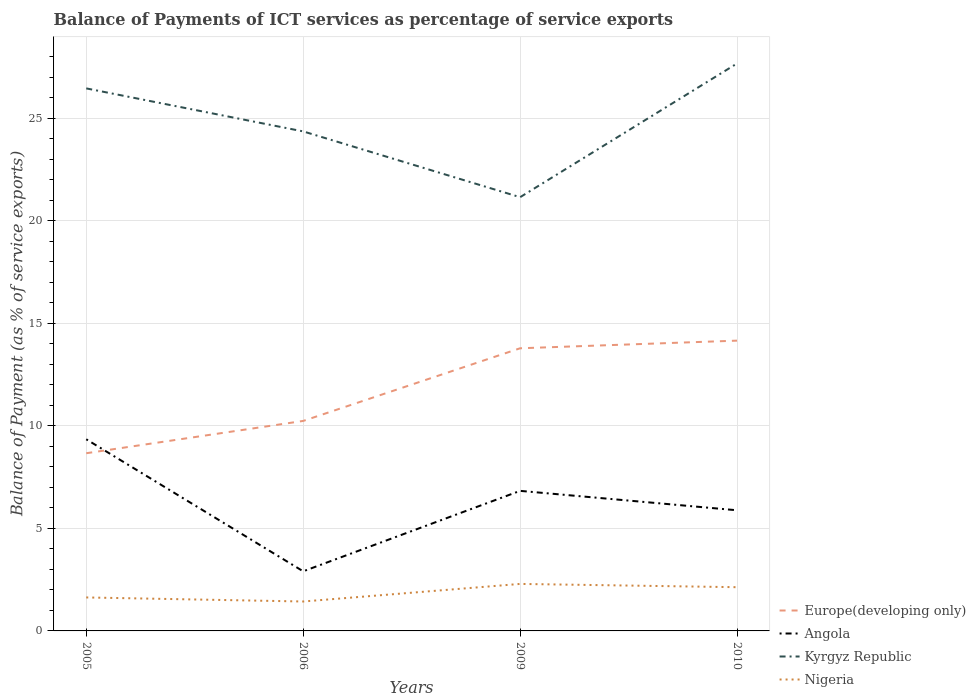How many different coloured lines are there?
Your answer should be very brief. 4. Does the line corresponding to Angola intersect with the line corresponding to Kyrgyz Republic?
Provide a succinct answer. No. Is the number of lines equal to the number of legend labels?
Your answer should be very brief. Yes. Across all years, what is the maximum balance of payments of ICT services in Kyrgyz Republic?
Your answer should be very brief. 21.14. What is the total balance of payments of ICT services in Angola in the graph?
Provide a short and direct response. 3.46. What is the difference between the highest and the second highest balance of payments of ICT services in Kyrgyz Republic?
Offer a very short reply. 6.52. What is the difference between the highest and the lowest balance of payments of ICT services in Europe(developing only)?
Your answer should be compact. 2. How many lines are there?
Provide a succinct answer. 4. How many years are there in the graph?
Your response must be concise. 4. Does the graph contain any zero values?
Keep it short and to the point. No. How are the legend labels stacked?
Offer a very short reply. Vertical. What is the title of the graph?
Provide a short and direct response. Balance of Payments of ICT services as percentage of service exports. Does "Other small states" appear as one of the legend labels in the graph?
Offer a terse response. No. What is the label or title of the X-axis?
Provide a short and direct response. Years. What is the label or title of the Y-axis?
Provide a short and direct response. Balance of Payment (as % of service exports). What is the Balance of Payment (as % of service exports) in Europe(developing only) in 2005?
Offer a terse response. 8.66. What is the Balance of Payment (as % of service exports) of Angola in 2005?
Ensure brevity in your answer.  9.34. What is the Balance of Payment (as % of service exports) in Kyrgyz Republic in 2005?
Give a very brief answer. 26.45. What is the Balance of Payment (as % of service exports) of Nigeria in 2005?
Provide a succinct answer. 1.63. What is the Balance of Payment (as % of service exports) of Europe(developing only) in 2006?
Ensure brevity in your answer.  10.24. What is the Balance of Payment (as % of service exports) of Angola in 2006?
Provide a short and direct response. 2.91. What is the Balance of Payment (as % of service exports) of Kyrgyz Republic in 2006?
Offer a terse response. 24.35. What is the Balance of Payment (as % of service exports) of Nigeria in 2006?
Provide a succinct answer. 1.43. What is the Balance of Payment (as % of service exports) in Europe(developing only) in 2009?
Provide a short and direct response. 13.78. What is the Balance of Payment (as % of service exports) of Angola in 2009?
Your answer should be compact. 6.83. What is the Balance of Payment (as % of service exports) of Kyrgyz Republic in 2009?
Your answer should be compact. 21.14. What is the Balance of Payment (as % of service exports) in Nigeria in 2009?
Offer a terse response. 2.29. What is the Balance of Payment (as % of service exports) of Europe(developing only) in 2010?
Keep it short and to the point. 14.15. What is the Balance of Payment (as % of service exports) in Angola in 2010?
Offer a very short reply. 5.88. What is the Balance of Payment (as % of service exports) of Kyrgyz Republic in 2010?
Give a very brief answer. 27.66. What is the Balance of Payment (as % of service exports) of Nigeria in 2010?
Offer a very short reply. 2.13. Across all years, what is the maximum Balance of Payment (as % of service exports) of Europe(developing only)?
Provide a succinct answer. 14.15. Across all years, what is the maximum Balance of Payment (as % of service exports) in Angola?
Provide a succinct answer. 9.34. Across all years, what is the maximum Balance of Payment (as % of service exports) in Kyrgyz Republic?
Offer a very short reply. 27.66. Across all years, what is the maximum Balance of Payment (as % of service exports) of Nigeria?
Your response must be concise. 2.29. Across all years, what is the minimum Balance of Payment (as % of service exports) in Europe(developing only)?
Your response must be concise. 8.66. Across all years, what is the minimum Balance of Payment (as % of service exports) of Angola?
Provide a short and direct response. 2.91. Across all years, what is the minimum Balance of Payment (as % of service exports) in Kyrgyz Republic?
Offer a very short reply. 21.14. Across all years, what is the minimum Balance of Payment (as % of service exports) in Nigeria?
Give a very brief answer. 1.43. What is the total Balance of Payment (as % of service exports) of Europe(developing only) in the graph?
Ensure brevity in your answer.  46.83. What is the total Balance of Payment (as % of service exports) of Angola in the graph?
Offer a terse response. 24.96. What is the total Balance of Payment (as % of service exports) of Kyrgyz Republic in the graph?
Your response must be concise. 99.6. What is the total Balance of Payment (as % of service exports) in Nigeria in the graph?
Make the answer very short. 7.49. What is the difference between the Balance of Payment (as % of service exports) in Europe(developing only) in 2005 and that in 2006?
Give a very brief answer. -1.57. What is the difference between the Balance of Payment (as % of service exports) of Angola in 2005 and that in 2006?
Provide a short and direct response. 6.44. What is the difference between the Balance of Payment (as % of service exports) in Kyrgyz Republic in 2005 and that in 2006?
Make the answer very short. 2.1. What is the difference between the Balance of Payment (as % of service exports) in Nigeria in 2005 and that in 2006?
Your answer should be compact. 0.2. What is the difference between the Balance of Payment (as % of service exports) of Europe(developing only) in 2005 and that in 2009?
Offer a very short reply. -5.12. What is the difference between the Balance of Payment (as % of service exports) in Angola in 2005 and that in 2009?
Your response must be concise. 2.51. What is the difference between the Balance of Payment (as % of service exports) in Kyrgyz Republic in 2005 and that in 2009?
Your answer should be very brief. 5.3. What is the difference between the Balance of Payment (as % of service exports) in Nigeria in 2005 and that in 2009?
Provide a short and direct response. -0.66. What is the difference between the Balance of Payment (as % of service exports) in Europe(developing only) in 2005 and that in 2010?
Offer a terse response. -5.49. What is the difference between the Balance of Payment (as % of service exports) of Angola in 2005 and that in 2010?
Give a very brief answer. 3.46. What is the difference between the Balance of Payment (as % of service exports) in Kyrgyz Republic in 2005 and that in 2010?
Ensure brevity in your answer.  -1.21. What is the difference between the Balance of Payment (as % of service exports) in Nigeria in 2005 and that in 2010?
Offer a terse response. -0.5. What is the difference between the Balance of Payment (as % of service exports) of Europe(developing only) in 2006 and that in 2009?
Provide a succinct answer. -3.54. What is the difference between the Balance of Payment (as % of service exports) of Angola in 2006 and that in 2009?
Your answer should be compact. -3.92. What is the difference between the Balance of Payment (as % of service exports) of Kyrgyz Republic in 2006 and that in 2009?
Offer a terse response. 3.21. What is the difference between the Balance of Payment (as % of service exports) in Nigeria in 2006 and that in 2009?
Provide a short and direct response. -0.86. What is the difference between the Balance of Payment (as % of service exports) of Europe(developing only) in 2006 and that in 2010?
Give a very brief answer. -3.91. What is the difference between the Balance of Payment (as % of service exports) of Angola in 2006 and that in 2010?
Ensure brevity in your answer.  -2.98. What is the difference between the Balance of Payment (as % of service exports) in Kyrgyz Republic in 2006 and that in 2010?
Keep it short and to the point. -3.31. What is the difference between the Balance of Payment (as % of service exports) in Nigeria in 2006 and that in 2010?
Offer a very short reply. -0.7. What is the difference between the Balance of Payment (as % of service exports) of Europe(developing only) in 2009 and that in 2010?
Offer a very short reply. -0.37. What is the difference between the Balance of Payment (as % of service exports) of Angola in 2009 and that in 2010?
Offer a very short reply. 0.95. What is the difference between the Balance of Payment (as % of service exports) of Kyrgyz Republic in 2009 and that in 2010?
Make the answer very short. -6.52. What is the difference between the Balance of Payment (as % of service exports) in Nigeria in 2009 and that in 2010?
Ensure brevity in your answer.  0.16. What is the difference between the Balance of Payment (as % of service exports) in Europe(developing only) in 2005 and the Balance of Payment (as % of service exports) in Angola in 2006?
Keep it short and to the point. 5.76. What is the difference between the Balance of Payment (as % of service exports) in Europe(developing only) in 2005 and the Balance of Payment (as % of service exports) in Kyrgyz Republic in 2006?
Give a very brief answer. -15.69. What is the difference between the Balance of Payment (as % of service exports) in Europe(developing only) in 2005 and the Balance of Payment (as % of service exports) in Nigeria in 2006?
Your answer should be compact. 7.23. What is the difference between the Balance of Payment (as % of service exports) of Angola in 2005 and the Balance of Payment (as % of service exports) of Kyrgyz Republic in 2006?
Make the answer very short. -15.01. What is the difference between the Balance of Payment (as % of service exports) in Angola in 2005 and the Balance of Payment (as % of service exports) in Nigeria in 2006?
Your response must be concise. 7.91. What is the difference between the Balance of Payment (as % of service exports) of Kyrgyz Republic in 2005 and the Balance of Payment (as % of service exports) of Nigeria in 2006?
Make the answer very short. 25.01. What is the difference between the Balance of Payment (as % of service exports) of Europe(developing only) in 2005 and the Balance of Payment (as % of service exports) of Angola in 2009?
Your answer should be very brief. 1.83. What is the difference between the Balance of Payment (as % of service exports) of Europe(developing only) in 2005 and the Balance of Payment (as % of service exports) of Kyrgyz Republic in 2009?
Ensure brevity in your answer.  -12.48. What is the difference between the Balance of Payment (as % of service exports) in Europe(developing only) in 2005 and the Balance of Payment (as % of service exports) in Nigeria in 2009?
Give a very brief answer. 6.37. What is the difference between the Balance of Payment (as % of service exports) of Angola in 2005 and the Balance of Payment (as % of service exports) of Kyrgyz Republic in 2009?
Offer a terse response. -11.8. What is the difference between the Balance of Payment (as % of service exports) of Angola in 2005 and the Balance of Payment (as % of service exports) of Nigeria in 2009?
Give a very brief answer. 7.05. What is the difference between the Balance of Payment (as % of service exports) in Kyrgyz Republic in 2005 and the Balance of Payment (as % of service exports) in Nigeria in 2009?
Offer a very short reply. 24.15. What is the difference between the Balance of Payment (as % of service exports) of Europe(developing only) in 2005 and the Balance of Payment (as % of service exports) of Angola in 2010?
Your answer should be very brief. 2.78. What is the difference between the Balance of Payment (as % of service exports) of Europe(developing only) in 2005 and the Balance of Payment (as % of service exports) of Kyrgyz Republic in 2010?
Your answer should be very brief. -19. What is the difference between the Balance of Payment (as % of service exports) in Europe(developing only) in 2005 and the Balance of Payment (as % of service exports) in Nigeria in 2010?
Make the answer very short. 6.53. What is the difference between the Balance of Payment (as % of service exports) in Angola in 2005 and the Balance of Payment (as % of service exports) in Kyrgyz Republic in 2010?
Offer a terse response. -18.32. What is the difference between the Balance of Payment (as % of service exports) in Angola in 2005 and the Balance of Payment (as % of service exports) in Nigeria in 2010?
Ensure brevity in your answer.  7.21. What is the difference between the Balance of Payment (as % of service exports) in Kyrgyz Republic in 2005 and the Balance of Payment (as % of service exports) in Nigeria in 2010?
Provide a succinct answer. 24.31. What is the difference between the Balance of Payment (as % of service exports) in Europe(developing only) in 2006 and the Balance of Payment (as % of service exports) in Angola in 2009?
Provide a succinct answer. 3.41. What is the difference between the Balance of Payment (as % of service exports) in Europe(developing only) in 2006 and the Balance of Payment (as % of service exports) in Kyrgyz Republic in 2009?
Make the answer very short. -10.91. What is the difference between the Balance of Payment (as % of service exports) in Europe(developing only) in 2006 and the Balance of Payment (as % of service exports) in Nigeria in 2009?
Ensure brevity in your answer.  7.94. What is the difference between the Balance of Payment (as % of service exports) in Angola in 2006 and the Balance of Payment (as % of service exports) in Kyrgyz Republic in 2009?
Provide a short and direct response. -18.24. What is the difference between the Balance of Payment (as % of service exports) in Angola in 2006 and the Balance of Payment (as % of service exports) in Nigeria in 2009?
Provide a short and direct response. 0.61. What is the difference between the Balance of Payment (as % of service exports) of Kyrgyz Republic in 2006 and the Balance of Payment (as % of service exports) of Nigeria in 2009?
Your answer should be compact. 22.06. What is the difference between the Balance of Payment (as % of service exports) in Europe(developing only) in 2006 and the Balance of Payment (as % of service exports) in Angola in 2010?
Provide a short and direct response. 4.36. What is the difference between the Balance of Payment (as % of service exports) in Europe(developing only) in 2006 and the Balance of Payment (as % of service exports) in Kyrgyz Republic in 2010?
Your response must be concise. -17.42. What is the difference between the Balance of Payment (as % of service exports) of Europe(developing only) in 2006 and the Balance of Payment (as % of service exports) of Nigeria in 2010?
Provide a short and direct response. 8.1. What is the difference between the Balance of Payment (as % of service exports) in Angola in 2006 and the Balance of Payment (as % of service exports) in Kyrgyz Republic in 2010?
Offer a terse response. -24.75. What is the difference between the Balance of Payment (as % of service exports) of Angola in 2006 and the Balance of Payment (as % of service exports) of Nigeria in 2010?
Provide a short and direct response. 0.77. What is the difference between the Balance of Payment (as % of service exports) in Kyrgyz Republic in 2006 and the Balance of Payment (as % of service exports) in Nigeria in 2010?
Ensure brevity in your answer.  22.22. What is the difference between the Balance of Payment (as % of service exports) of Europe(developing only) in 2009 and the Balance of Payment (as % of service exports) of Angola in 2010?
Provide a short and direct response. 7.9. What is the difference between the Balance of Payment (as % of service exports) of Europe(developing only) in 2009 and the Balance of Payment (as % of service exports) of Kyrgyz Republic in 2010?
Your answer should be compact. -13.88. What is the difference between the Balance of Payment (as % of service exports) of Europe(developing only) in 2009 and the Balance of Payment (as % of service exports) of Nigeria in 2010?
Provide a short and direct response. 11.65. What is the difference between the Balance of Payment (as % of service exports) of Angola in 2009 and the Balance of Payment (as % of service exports) of Kyrgyz Republic in 2010?
Offer a terse response. -20.83. What is the difference between the Balance of Payment (as % of service exports) of Angola in 2009 and the Balance of Payment (as % of service exports) of Nigeria in 2010?
Provide a succinct answer. 4.7. What is the difference between the Balance of Payment (as % of service exports) of Kyrgyz Republic in 2009 and the Balance of Payment (as % of service exports) of Nigeria in 2010?
Provide a succinct answer. 19.01. What is the average Balance of Payment (as % of service exports) of Europe(developing only) per year?
Keep it short and to the point. 11.71. What is the average Balance of Payment (as % of service exports) of Angola per year?
Provide a succinct answer. 6.24. What is the average Balance of Payment (as % of service exports) in Kyrgyz Republic per year?
Offer a terse response. 24.9. What is the average Balance of Payment (as % of service exports) of Nigeria per year?
Offer a very short reply. 1.87. In the year 2005, what is the difference between the Balance of Payment (as % of service exports) of Europe(developing only) and Balance of Payment (as % of service exports) of Angola?
Offer a very short reply. -0.68. In the year 2005, what is the difference between the Balance of Payment (as % of service exports) of Europe(developing only) and Balance of Payment (as % of service exports) of Kyrgyz Republic?
Make the answer very short. -17.78. In the year 2005, what is the difference between the Balance of Payment (as % of service exports) in Europe(developing only) and Balance of Payment (as % of service exports) in Nigeria?
Your response must be concise. 7.03. In the year 2005, what is the difference between the Balance of Payment (as % of service exports) of Angola and Balance of Payment (as % of service exports) of Kyrgyz Republic?
Your answer should be compact. -17.1. In the year 2005, what is the difference between the Balance of Payment (as % of service exports) of Angola and Balance of Payment (as % of service exports) of Nigeria?
Your answer should be very brief. 7.71. In the year 2005, what is the difference between the Balance of Payment (as % of service exports) of Kyrgyz Republic and Balance of Payment (as % of service exports) of Nigeria?
Offer a terse response. 24.81. In the year 2006, what is the difference between the Balance of Payment (as % of service exports) of Europe(developing only) and Balance of Payment (as % of service exports) of Angola?
Provide a succinct answer. 7.33. In the year 2006, what is the difference between the Balance of Payment (as % of service exports) of Europe(developing only) and Balance of Payment (as % of service exports) of Kyrgyz Republic?
Provide a short and direct response. -14.11. In the year 2006, what is the difference between the Balance of Payment (as % of service exports) in Europe(developing only) and Balance of Payment (as % of service exports) in Nigeria?
Give a very brief answer. 8.8. In the year 2006, what is the difference between the Balance of Payment (as % of service exports) in Angola and Balance of Payment (as % of service exports) in Kyrgyz Republic?
Your response must be concise. -21.44. In the year 2006, what is the difference between the Balance of Payment (as % of service exports) of Angola and Balance of Payment (as % of service exports) of Nigeria?
Your answer should be compact. 1.47. In the year 2006, what is the difference between the Balance of Payment (as % of service exports) in Kyrgyz Republic and Balance of Payment (as % of service exports) in Nigeria?
Provide a succinct answer. 22.92. In the year 2009, what is the difference between the Balance of Payment (as % of service exports) in Europe(developing only) and Balance of Payment (as % of service exports) in Angola?
Provide a short and direct response. 6.95. In the year 2009, what is the difference between the Balance of Payment (as % of service exports) of Europe(developing only) and Balance of Payment (as % of service exports) of Kyrgyz Republic?
Make the answer very short. -7.36. In the year 2009, what is the difference between the Balance of Payment (as % of service exports) in Europe(developing only) and Balance of Payment (as % of service exports) in Nigeria?
Ensure brevity in your answer.  11.49. In the year 2009, what is the difference between the Balance of Payment (as % of service exports) of Angola and Balance of Payment (as % of service exports) of Kyrgyz Republic?
Your answer should be compact. -14.31. In the year 2009, what is the difference between the Balance of Payment (as % of service exports) in Angola and Balance of Payment (as % of service exports) in Nigeria?
Your response must be concise. 4.54. In the year 2009, what is the difference between the Balance of Payment (as % of service exports) of Kyrgyz Republic and Balance of Payment (as % of service exports) of Nigeria?
Offer a very short reply. 18.85. In the year 2010, what is the difference between the Balance of Payment (as % of service exports) of Europe(developing only) and Balance of Payment (as % of service exports) of Angola?
Offer a terse response. 8.27. In the year 2010, what is the difference between the Balance of Payment (as % of service exports) in Europe(developing only) and Balance of Payment (as % of service exports) in Kyrgyz Republic?
Provide a succinct answer. -13.51. In the year 2010, what is the difference between the Balance of Payment (as % of service exports) in Europe(developing only) and Balance of Payment (as % of service exports) in Nigeria?
Make the answer very short. 12.02. In the year 2010, what is the difference between the Balance of Payment (as % of service exports) in Angola and Balance of Payment (as % of service exports) in Kyrgyz Republic?
Your response must be concise. -21.78. In the year 2010, what is the difference between the Balance of Payment (as % of service exports) of Angola and Balance of Payment (as % of service exports) of Nigeria?
Your answer should be very brief. 3.75. In the year 2010, what is the difference between the Balance of Payment (as % of service exports) of Kyrgyz Republic and Balance of Payment (as % of service exports) of Nigeria?
Make the answer very short. 25.53. What is the ratio of the Balance of Payment (as % of service exports) of Europe(developing only) in 2005 to that in 2006?
Offer a very short reply. 0.85. What is the ratio of the Balance of Payment (as % of service exports) of Angola in 2005 to that in 2006?
Provide a succinct answer. 3.21. What is the ratio of the Balance of Payment (as % of service exports) in Kyrgyz Republic in 2005 to that in 2006?
Your response must be concise. 1.09. What is the ratio of the Balance of Payment (as % of service exports) of Nigeria in 2005 to that in 2006?
Provide a succinct answer. 1.14. What is the ratio of the Balance of Payment (as % of service exports) of Europe(developing only) in 2005 to that in 2009?
Your response must be concise. 0.63. What is the ratio of the Balance of Payment (as % of service exports) in Angola in 2005 to that in 2009?
Offer a terse response. 1.37. What is the ratio of the Balance of Payment (as % of service exports) of Kyrgyz Republic in 2005 to that in 2009?
Your answer should be compact. 1.25. What is the ratio of the Balance of Payment (as % of service exports) in Nigeria in 2005 to that in 2009?
Provide a succinct answer. 0.71. What is the ratio of the Balance of Payment (as % of service exports) of Europe(developing only) in 2005 to that in 2010?
Keep it short and to the point. 0.61. What is the ratio of the Balance of Payment (as % of service exports) in Angola in 2005 to that in 2010?
Give a very brief answer. 1.59. What is the ratio of the Balance of Payment (as % of service exports) of Kyrgyz Republic in 2005 to that in 2010?
Your response must be concise. 0.96. What is the ratio of the Balance of Payment (as % of service exports) in Nigeria in 2005 to that in 2010?
Offer a terse response. 0.77. What is the ratio of the Balance of Payment (as % of service exports) in Europe(developing only) in 2006 to that in 2009?
Provide a short and direct response. 0.74. What is the ratio of the Balance of Payment (as % of service exports) in Angola in 2006 to that in 2009?
Keep it short and to the point. 0.43. What is the ratio of the Balance of Payment (as % of service exports) of Kyrgyz Republic in 2006 to that in 2009?
Your answer should be very brief. 1.15. What is the ratio of the Balance of Payment (as % of service exports) in Nigeria in 2006 to that in 2009?
Your response must be concise. 0.63. What is the ratio of the Balance of Payment (as % of service exports) of Europe(developing only) in 2006 to that in 2010?
Make the answer very short. 0.72. What is the ratio of the Balance of Payment (as % of service exports) of Angola in 2006 to that in 2010?
Ensure brevity in your answer.  0.49. What is the ratio of the Balance of Payment (as % of service exports) of Kyrgyz Republic in 2006 to that in 2010?
Provide a succinct answer. 0.88. What is the ratio of the Balance of Payment (as % of service exports) in Nigeria in 2006 to that in 2010?
Keep it short and to the point. 0.67. What is the ratio of the Balance of Payment (as % of service exports) of Europe(developing only) in 2009 to that in 2010?
Provide a succinct answer. 0.97. What is the ratio of the Balance of Payment (as % of service exports) in Angola in 2009 to that in 2010?
Keep it short and to the point. 1.16. What is the ratio of the Balance of Payment (as % of service exports) of Kyrgyz Republic in 2009 to that in 2010?
Provide a succinct answer. 0.76. What is the ratio of the Balance of Payment (as % of service exports) in Nigeria in 2009 to that in 2010?
Offer a terse response. 1.07. What is the difference between the highest and the second highest Balance of Payment (as % of service exports) of Europe(developing only)?
Make the answer very short. 0.37. What is the difference between the highest and the second highest Balance of Payment (as % of service exports) of Angola?
Offer a terse response. 2.51. What is the difference between the highest and the second highest Balance of Payment (as % of service exports) in Kyrgyz Republic?
Ensure brevity in your answer.  1.21. What is the difference between the highest and the second highest Balance of Payment (as % of service exports) of Nigeria?
Make the answer very short. 0.16. What is the difference between the highest and the lowest Balance of Payment (as % of service exports) of Europe(developing only)?
Your answer should be compact. 5.49. What is the difference between the highest and the lowest Balance of Payment (as % of service exports) in Angola?
Keep it short and to the point. 6.44. What is the difference between the highest and the lowest Balance of Payment (as % of service exports) of Kyrgyz Republic?
Offer a very short reply. 6.52. What is the difference between the highest and the lowest Balance of Payment (as % of service exports) of Nigeria?
Provide a succinct answer. 0.86. 